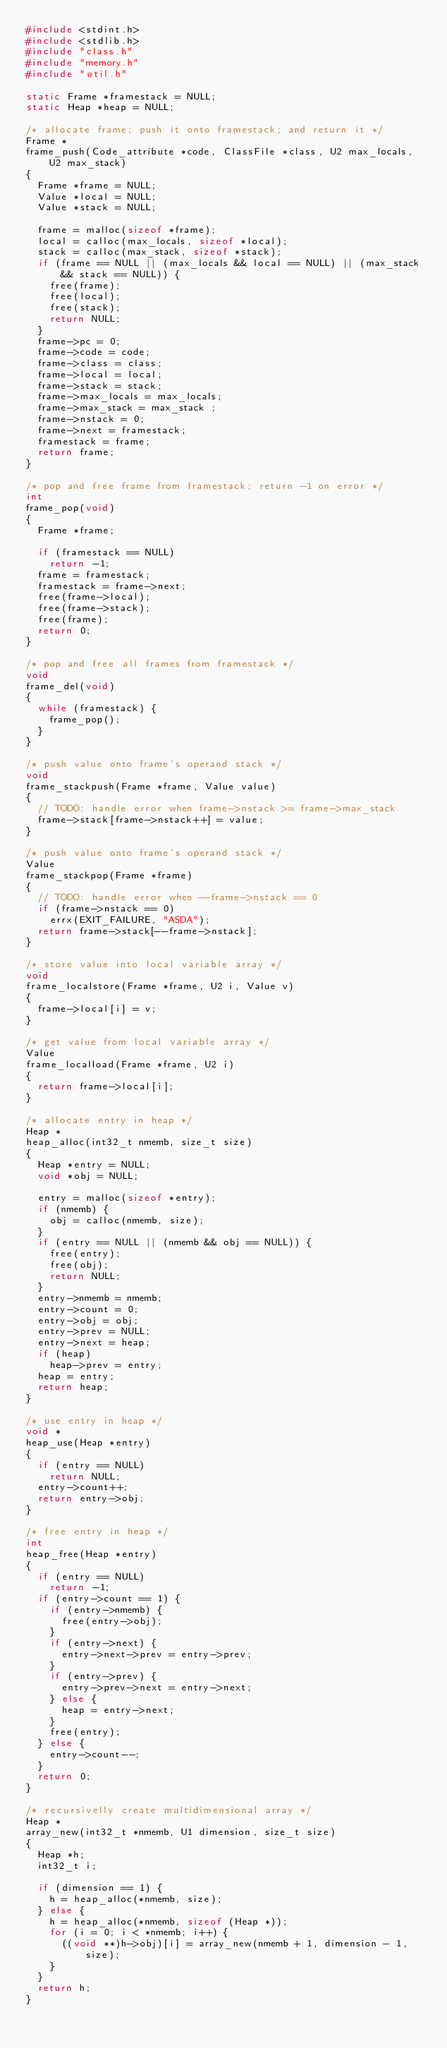<code> <loc_0><loc_0><loc_500><loc_500><_C_>#include <stdint.h>
#include <stdlib.h>
#include "class.h"
#include "memory.h"
#include "util.h"

static Frame *framestack = NULL;
static Heap *heap = NULL;

/* allocate frame; push it onto framestack; and return it */
Frame *
frame_push(Code_attribute *code, ClassFile *class, U2 max_locals, U2 max_stack)
{
	Frame *frame = NULL;
	Value *local = NULL;
	Value *stack = NULL;

	frame = malloc(sizeof *frame);
	local = calloc(max_locals, sizeof *local);
	stack = calloc(max_stack, sizeof *stack);
	if (frame == NULL || (max_locals && local == NULL) || (max_stack && stack == NULL)) {
		free(frame);
		free(local);
		free(stack);
		return NULL;
	}
	frame->pc = 0;
	frame->code = code;
	frame->class = class;
	frame->local = local;
	frame->stack = stack;
	frame->max_locals = max_locals;
	frame->max_stack = max_stack ;
	frame->nstack = 0;
	frame->next = framestack;
	framestack = frame;
	return frame;
}

/* pop and free frame from framestack; return -1 on error */
int
frame_pop(void)
{
	Frame *frame;

	if (framestack == NULL)
		return -1;
	frame = framestack;
	framestack = frame->next;
	free(frame->local);
	free(frame->stack);
	free(frame);
	return 0;
}

/* pop and free all frames from framestack */
void
frame_del(void)
{
	while (framestack) {
		frame_pop();
	}
}

/* push value onto frame's operand stack */
void
frame_stackpush(Frame *frame, Value value)
{
	// TODO: handle error when frame->nstack >= frame->max_stack
	frame->stack[frame->nstack++] = value;
}

/* push value onto frame's operand stack */
Value
frame_stackpop(Frame *frame)
{
	// TODO: handle error when --frame->nstack == 0
	if (frame->nstack == 0)
		errx(EXIT_FAILURE, "ASDA");
	return frame->stack[--frame->nstack];
}

/* store value into local variable array */
void
frame_localstore(Frame *frame, U2 i, Value v)
{
	frame->local[i] = v;
}

/* get value from local variable array */
Value
frame_localload(Frame *frame, U2 i)
{
	return frame->local[i];
}

/* allocate entry in heap */
Heap *
heap_alloc(int32_t nmemb, size_t size)
{
	Heap *entry = NULL;
	void *obj = NULL;

	entry = malloc(sizeof *entry);
	if (nmemb) {
		obj = calloc(nmemb, size);
	}
	if (entry == NULL || (nmemb && obj == NULL)) {
		free(entry);
		free(obj);
		return NULL;
	}
	entry->nmemb = nmemb;
	entry->count = 0;
	entry->obj = obj;
	entry->prev = NULL;
	entry->next = heap;
	if (heap)
		heap->prev = entry;
	heap = entry;
	return heap;
}

/* use entry in heap */
void *
heap_use(Heap *entry)
{
	if (entry == NULL)
		return NULL;
	entry->count++;
	return entry->obj;
}

/* free entry in heap */
int
heap_free(Heap *entry)
{
	if (entry == NULL)
		return -1;
	if (entry->count == 1) {
		if (entry->nmemb) {
			free(entry->obj);
		}
		if (entry->next) {
			entry->next->prev = entry->prev;
		}
		if (entry->prev) {
			entry->prev->next = entry->next;
		} else {
			heap = entry->next;
		}
		free(entry);
	} else {
		entry->count--;
	}
	return 0;
}

/* recursivelly create multidimensional array */
Heap *
array_new(int32_t *nmemb, U1 dimension, size_t size)
{
	Heap *h;
	int32_t i;

	if (dimension == 1) {
		h = heap_alloc(*nmemb, size);
	} else {
		h = heap_alloc(*nmemb, sizeof (Heap *));
		for (i = 0; i < *nmemb; i++) {
			((void **)h->obj)[i] = array_new(nmemb + 1, dimension - 1, size);
		}
	}
	return h;
}
</code> 